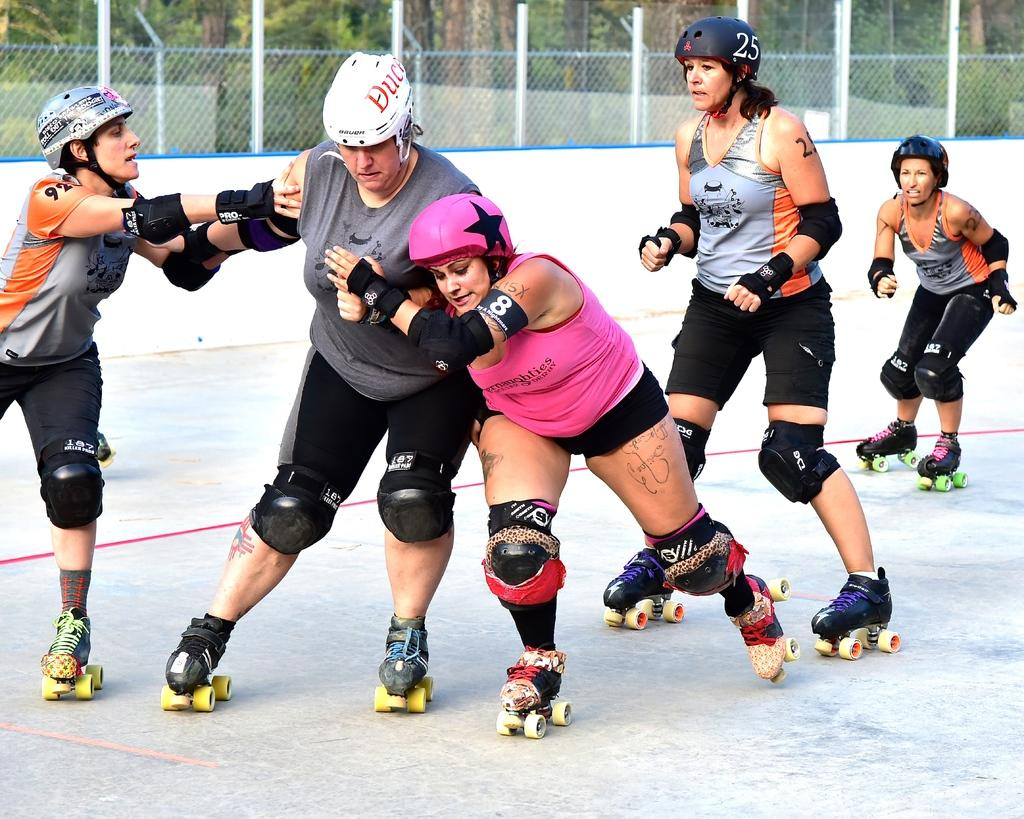What are the people in the image wearing on their feet? The people in the image are wearing roller skates. What can be seen in the background of the image? There are trees and a fence in the background of the image. What is visible at the bottom of the image? The ground is visible at the bottom of the image. What type of substance is being sprayed by the orange tree in the image? There is no orange tree or substance being sprayed in the image. 